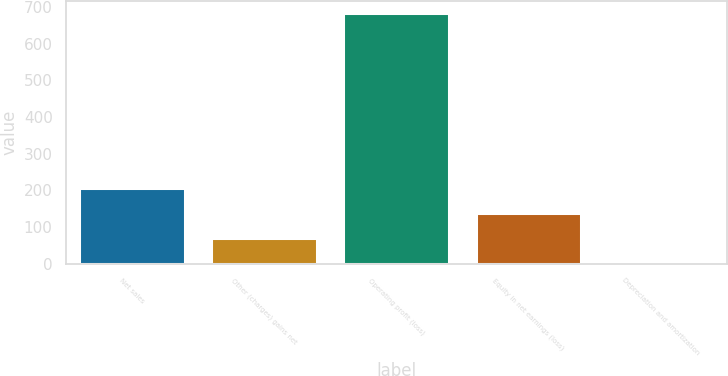<chart> <loc_0><loc_0><loc_500><loc_500><bar_chart><fcel>Net sales<fcel>Other (charges) gains net<fcel>Operating profit (loss)<fcel>Equity in net earnings (loss)<fcel>Depreciation and amortization<nl><fcel>207.7<fcel>71.9<fcel>683<fcel>139.8<fcel>4<nl></chart> 